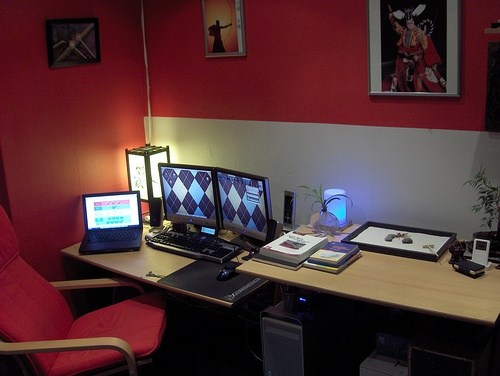Describe the objects in this image and their specific colors. I can see chair in maroon, brown, black, and gray tones, tv in maroon, black, navy, white, and purple tones, laptop in maroon, white, navy, black, and cyan tones, tv in maroon, black, navy, and gray tones, and potted plant in maroon, gray, and black tones in this image. 